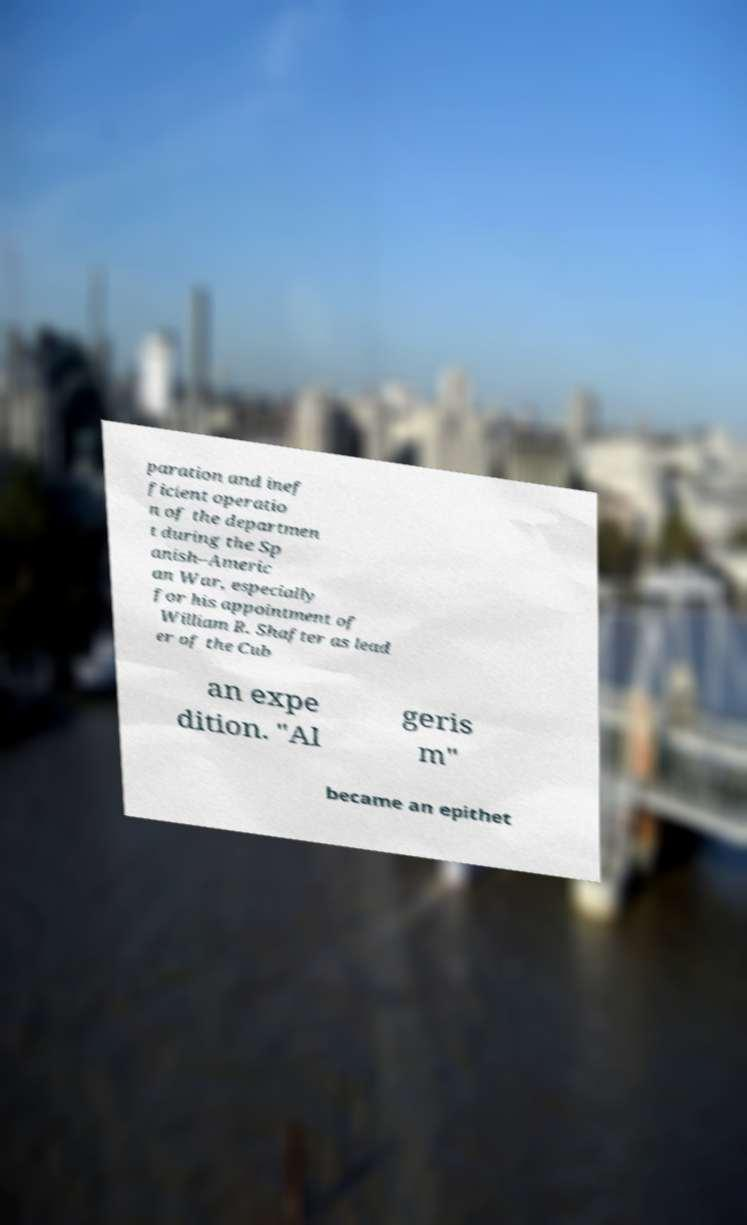There's text embedded in this image that I need extracted. Can you transcribe it verbatim? paration and inef ficient operatio n of the departmen t during the Sp anish–Americ an War, especially for his appointment of William R. Shafter as lead er of the Cub an expe dition. "Al geris m" became an epithet 